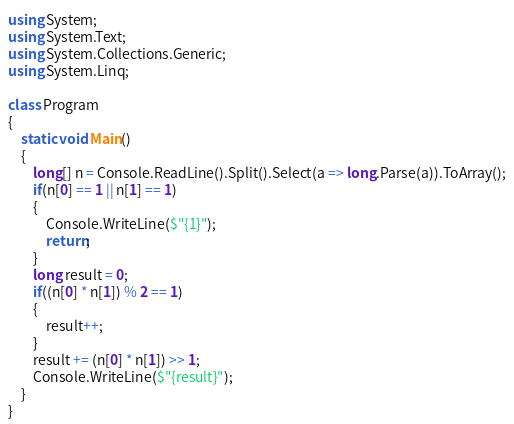Convert code to text. <code><loc_0><loc_0><loc_500><loc_500><_C#_>using System;
using System.Text;
using System.Collections.Generic;
using System.Linq;

class Program
{
    static void Main()
    {
        long[] n = Console.ReadLine().Split().Select(a => long.Parse(a)).ToArray();
        if(n[0] == 1 || n[1] == 1)
        {
            Console.WriteLine($"{1}");
            return;
        }
        long result = 0;
        if((n[0] * n[1]) % 2 == 1)
        {
            result++;
        }
        result += (n[0] * n[1]) >> 1;
        Console.WriteLine($"{result}");
    }
}</code> 